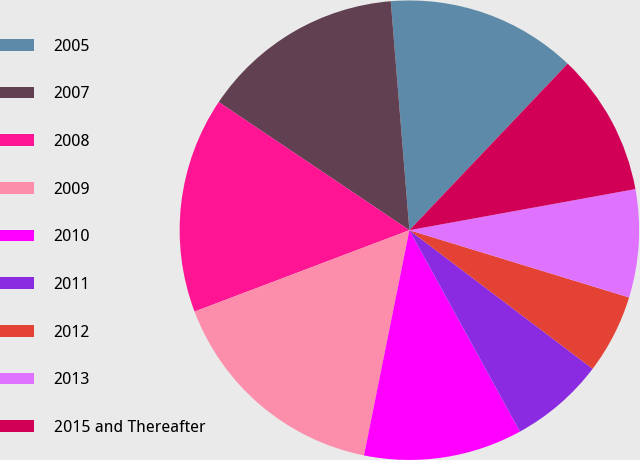Convert chart to OTSL. <chart><loc_0><loc_0><loc_500><loc_500><pie_chart><fcel>2005<fcel>2007<fcel>2008<fcel>2009<fcel>2010<fcel>2011<fcel>2012<fcel>2013<fcel>2015 and Thereafter<nl><fcel>13.39%<fcel>14.29%<fcel>15.18%<fcel>16.07%<fcel>11.16%<fcel>6.7%<fcel>5.58%<fcel>7.59%<fcel>10.04%<nl></chart> 